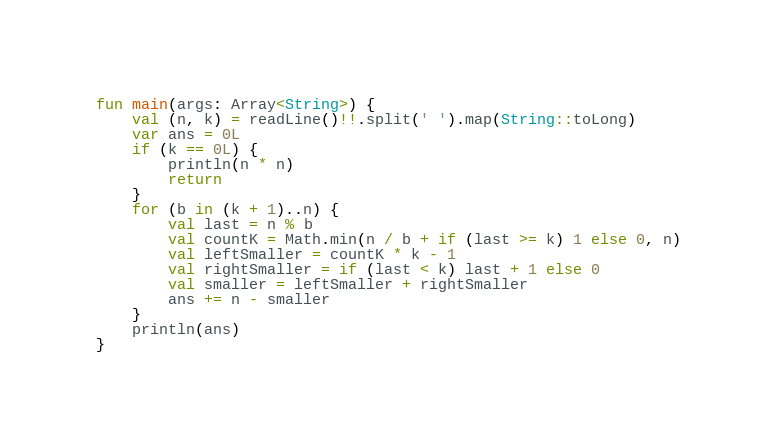Convert code to text. <code><loc_0><loc_0><loc_500><loc_500><_Kotlin_>fun main(args: Array<String>) {
    val (n, k) = readLine()!!.split(' ').map(String::toLong)
    var ans = 0L
    if (k == 0L) {
        println(n * n)
        return
    }
    for (b in (k + 1)..n) {
        val last = n % b
        val countK = Math.min(n / b + if (last >= k) 1 else 0, n)
        val leftSmaller = countK * k - 1
        val rightSmaller = if (last < k) last + 1 else 0
        val smaller = leftSmaller + rightSmaller
        ans += n - smaller
    }
    println(ans)
}
</code> 